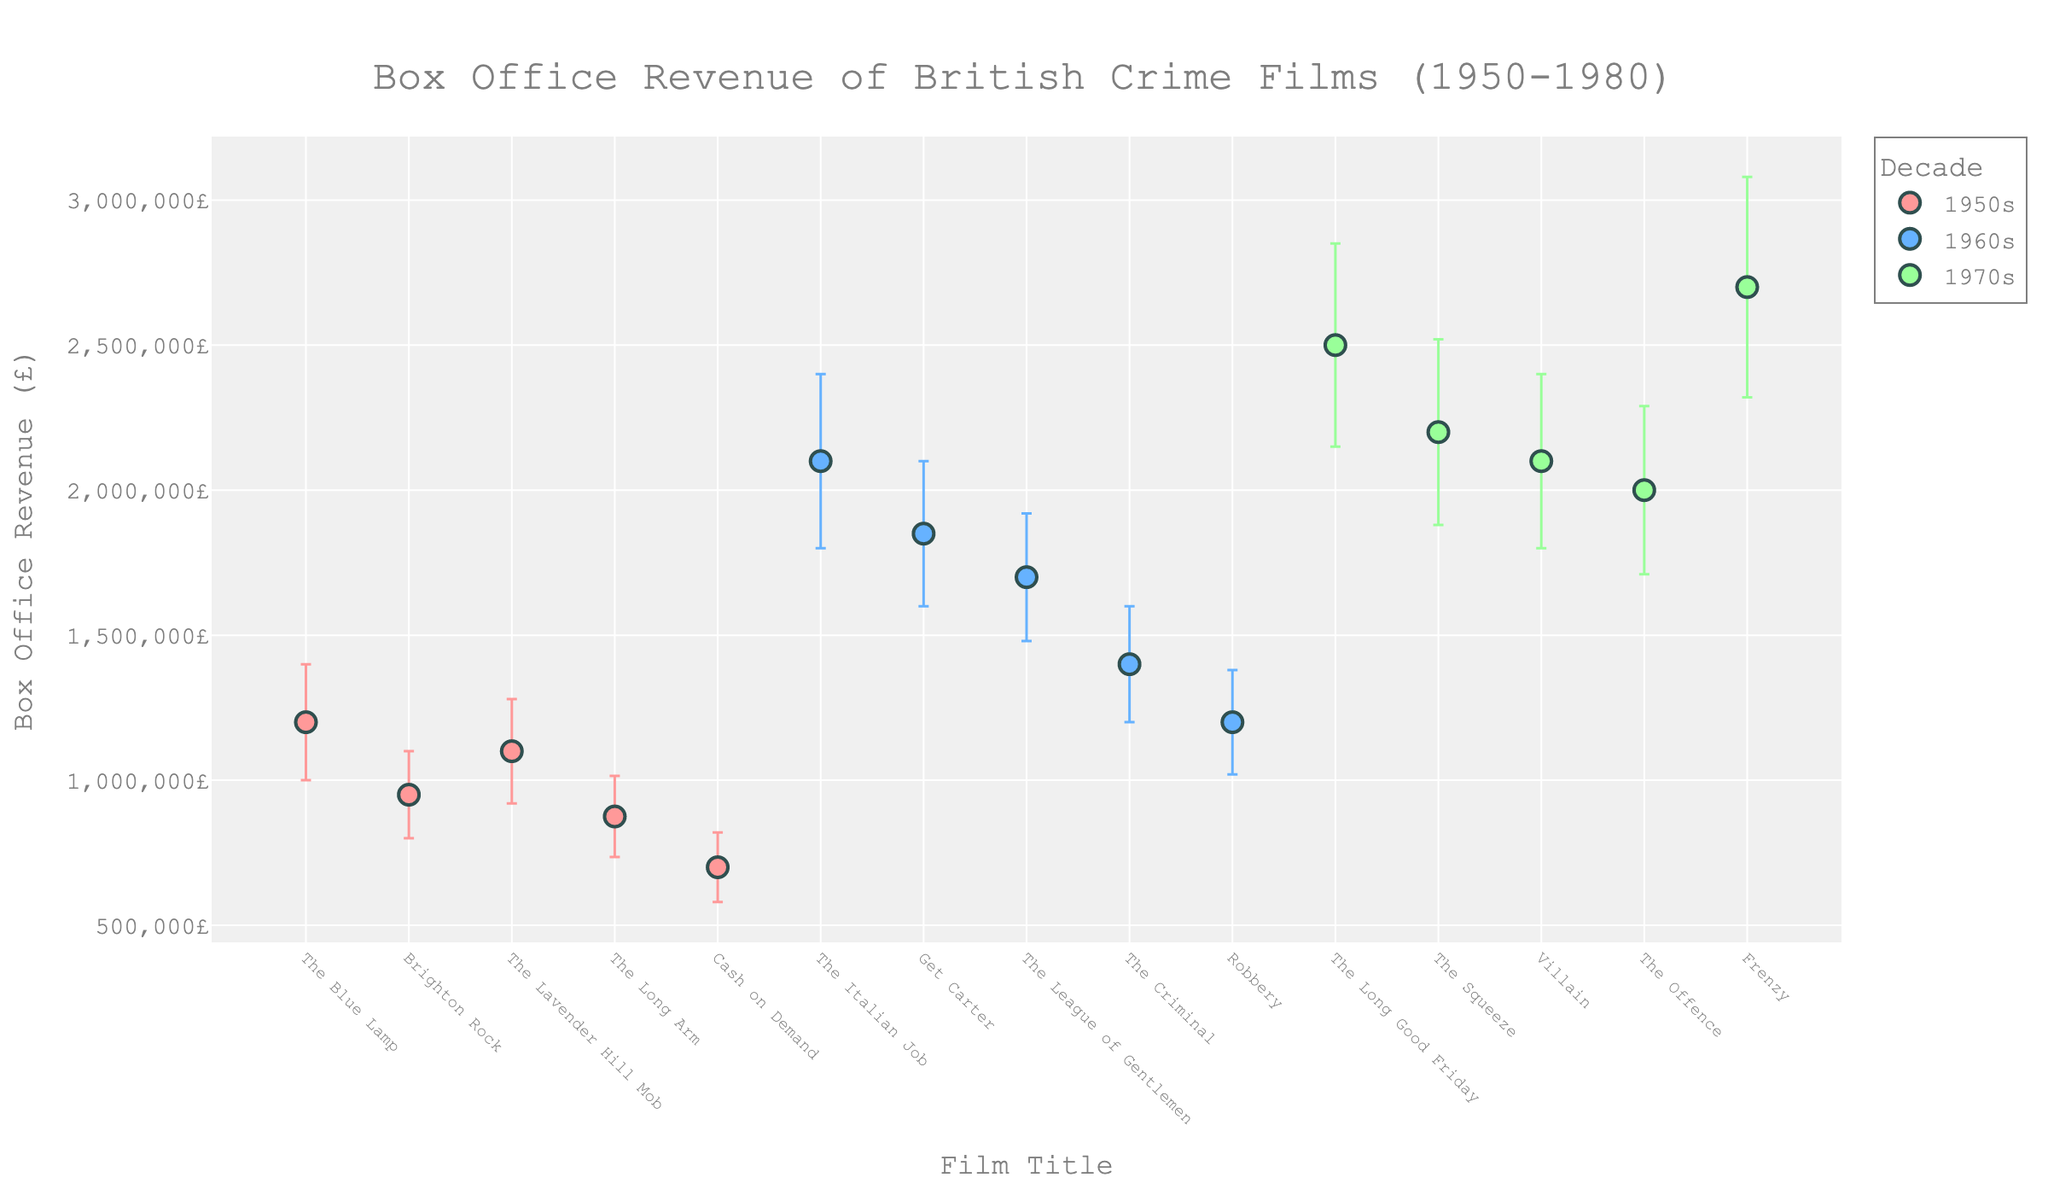What's the title of the plot? The title of the plot is displayed at the top center of the figure. It reads "Box Office Revenue of British Crime Films (1950-1980)".
Answer: Box Office Revenue of British Crime Films (1950-1980) How many British crime films from the 1950s are represented in the plot? The plot shows a set of data points for each film. Films from the 1950s can be identified by their unique color. There are 5 such data points for the 1950s.
Answer: 5 Which film had the highest box office revenue in the 1970s? Looking at the y-axis values corresponding to the films in the 1970s, "Frenzy" had the highest box office revenue as it is the highest point among the films from that decade.
Answer: Frenzy What's the average box office revenue for films in the 1960s? Add up the box office revenues of the films from the 1960s and divide by the number of films. Revenues are 2100000, 1850000, 1700000, 1400000, and 1200000. Total revenue is 8250000. There are 5 films, so the average is 8250000/5 = 1650000.
Answer: 1650000 Which decade has the highest variability in box office revenues? Variability can be inferred from the length of the error bars. The decade with the longest error bars on average is the 1970s, indicating the highest variability.
Answer: 1970s Compare the average box office revenue for the 1950s and the 1970s. Which is higher? Compute the average box office revenue for both decades. For the 1950s: (1200000 + 950000 + 1100000 + 875000 + 700000) / 5 = 965000. For the 1970s: (2500000 + 2200000 + 2100000 + 2000000 + 2700000) / 5 = 2300000. Comparing these, 2300000 is higher than 965000.
Answer: 1970s Which film has the smallest standard deviation in box office revenue? Examine the lengths of the error bars to determine the smallest. "Cash on Demand" from the 1950s has the smallest error bar representing the standard deviation of 120000.
Answer: Cash on Demand Are there any films with the same box office revenue? Check the y-axis positions of all data points. None of the films share the exact same position on the y-axis, hence no films have identical box office revenue.
Answer: No What's the difference in box office revenue between "The Long Good Friday" and "The Italian Job"? Subtract the box office revenue of "The Italian Job" from that of "The Long Good Friday". The values are 2500000 and 2100000 respectively. Difference is 2500000 - 2100000 = 400000.
Answer: 400000 